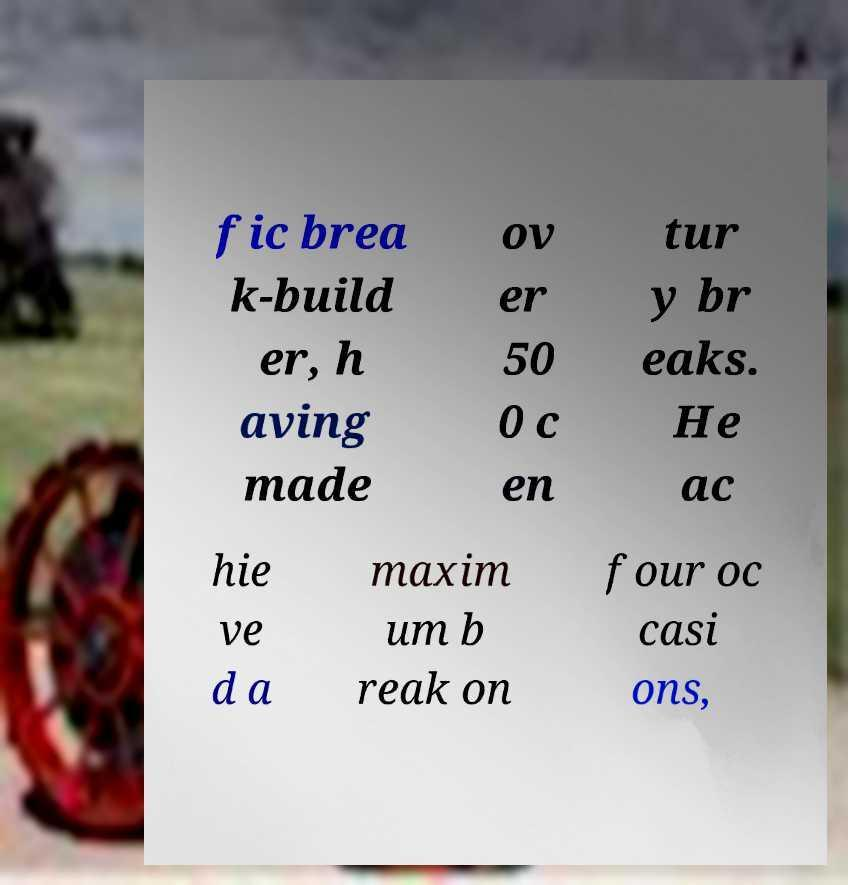I need the written content from this picture converted into text. Can you do that? fic brea k-build er, h aving made ov er 50 0 c en tur y br eaks. He ac hie ve d a maxim um b reak on four oc casi ons, 